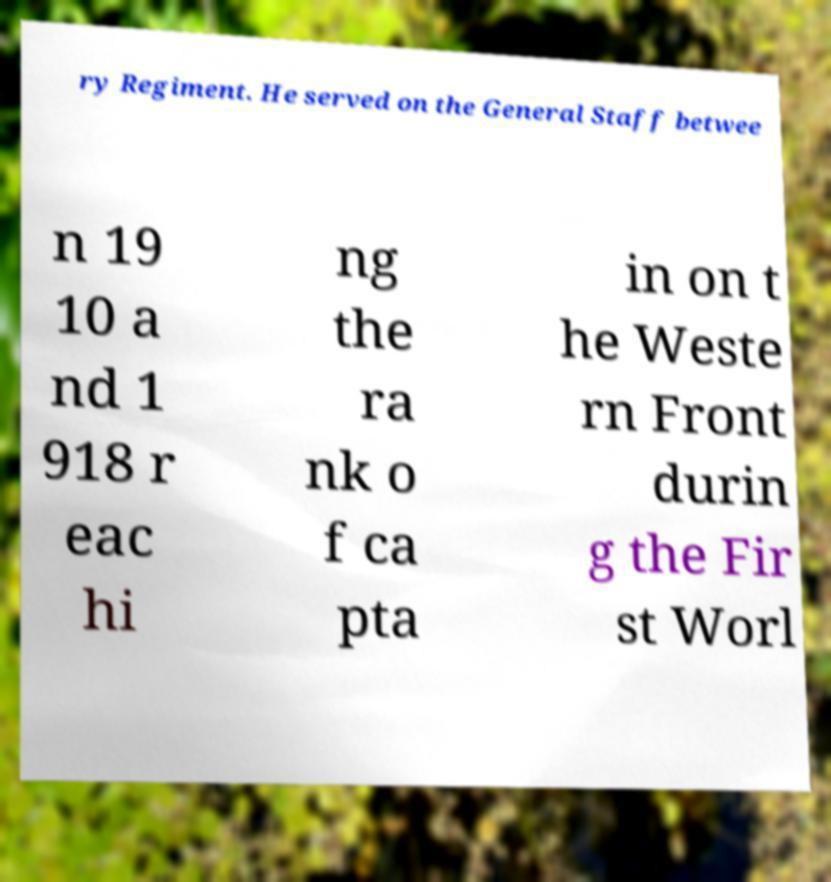Please read and relay the text visible in this image. What does it say? ry Regiment. He served on the General Staff betwee n 19 10 a nd 1 918 r eac hi ng the ra nk o f ca pta in on t he Weste rn Front durin g the Fir st Worl 